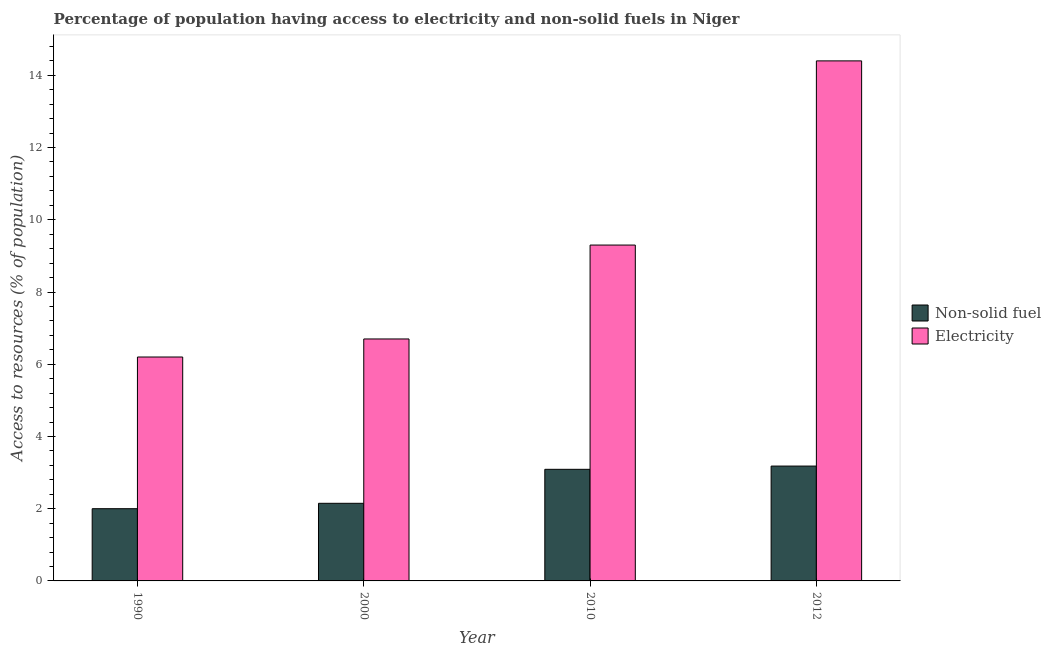How many groups of bars are there?
Give a very brief answer. 4. How many bars are there on the 3rd tick from the left?
Ensure brevity in your answer.  2. In how many cases, is the number of bars for a given year not equal to the number of legend labels?
Keep it short and to the point. 0. What is the percentage of population having access to non-solid fuel in 2000?
Provide a short and direct response. 2.15. Across all years, what is the maximum percentage of population having access to non-solid fuel?
Ensure brevity in your answer.  3.18. Across all years, what is the minimum percentage of population having access to non-solid fuel?
Give a very brief answer. 2. What is the total percentage of population having access to non-solid fuel in the graph?
Provide a short and direct response. 10.42. What is the difference between the percentage of population having access to non-solid fuel in 1990 and that in 2000?
Provide a succinct answer. -0.15. What is the difference between the percentage of population having access to electricity in 1990 and the percentage of population having access to non-solid fuel in 2000?
Your response must be concise. -0.5. What is the average percentage of population having access to non-solid fuel per year?
Offer a terse response. 2.6. In the year 1990, what is the difference between the percentage of population having access to electricity and percentage of population having access to non-solid fuel?
Offer a terse response. 0. What is the ratio of the percentage of population having access to electricity in 2010 to that in 2012?
Offer a very short reply. 0.65. What is the difference between the highest and the second highest percentage of population having access to non-solid fuel?
Offer a terse response. 0.09. What is the difference between the highest and the lowest percentage of population having access to electricity?
Offer a terse response. 8.2. Is the sum of the percentage of population having access to electricity in 2000 and 2012 greater than the maximum percentage of population having access to non-solid fuel across all years?
Make the answer very short. Yes. What does the 2nd bar from the left in 1990 represents?
Provide a short and direct response. Electricity. What does the 2nd bar from the right in 2000 represents?
Ensure brevity in your answer.  Non-solid fuel. How many bars are there?
Keep it short and to the point. 8. Are all the bars in the graph horizontal?
Keep it short and to the point. No. Are the values on the major ticks of Y-axis written in scientific E-notation?
Give a very brief answer. No. Does the graph contain grids?
Provide a succinct answer. No. How many legend labels are there?
Give a very brief answer. 2. What is the title of the graph?
Offer a terse response. Percentage of population having access to electricity and non-solid fuels in Niger. Does "constant 2005 US$" appear as one of the legend labels in the graph?
Keep it short and to the point. No. What is the label or title of the X-axis?
Keep it short and to the point. Year. What is the label or title of the Y-axis?
Provide a short and direct response. Access to resources (% of population). What is the Access to resources (% of population) in Non-solid fuel in 1990?
Ensure brevity in your answer.  2. What is the Access to resources (% of population) in Electricity in 1990?
Your answer should be very brief. 6.2. What is the Access to resources (% of population) in Non-solid fuel in 2000?
Offer a terse response. 2.15. What is the Access to resources (% of population) in Non-solid fuel in 2010?
Provide a succinct answer. 3.09. What is the Access to resources (% of population) in Electricity in 2010?
Your answer should be compact. 9.3. What is the Access to resources (% of population) of Non-solid fuel in 2012?
Keep it short and to the point. 3.18. Across all years, what is the maximum Access to resources (% of population) of Non-solid fuel?
Give a very brief answer. 3.18. Across all years, what is the minimum Access to resources (% of population) of Non-solid fuel?
Ensure brevity in your answer.  2. Across all years, what is the minimum Access to resources (% of population) in Electricity?
Keep it short and to the point. 6.2. What is the total Access to resources (% of population) in Non-solid fuel in the graph?
Keep it short and to the point. 10.42. What is the total Access to resources (% of population) in Electricity in the graph?
Provide a short and direct response. 36.6. What is the difference between the Access to resources (% of population) in Non-solid fuel in 1990 and that in 2000?
Offer a terse response. -0.15. What is the difference between the Access to resources (% of population) of Electricity in 1990 and that in 2000?
Your response must be concise. -0.5. What is the difference between the Access to resources (% of population) in Non-solid fuel in 1990 and that in 2010?
Make the answer very short. -1.09. What is the difference between the Access to resources (% of population) of Non-solid fuel in 1990 and that in 2012?
Provide a short and direct response. -1.18. What is the difference between the Access to resources (% of population) in Non-solid fuel in 2000 and that in 2010?
Provide a succinct answer. -0.94. What is the difference between the Access to resources (% of population) in Electricity in 2000 and that in 2010?
Your response must be concise. -2.6. What is the difference between the Access to resources (% of population) of Non-solid fuel in 2000 and that in 2012?
Your answer should be very brief. -1.03. What is the difference between the Access to resources (% of population) of Non-solid fuel in 2010 and that in 2012?
Keep it short and to the point. -0.09. What is the difference between the Access to resources (% of population) in Electricity in 2010 and that in 2012?
Give a very brief answer. -5.1. What is the difference between the Access to resources (% of population) in Non-solid fuel in 1990 and the Access to resources (% of population) in Electricity in 2000?
Give a very brief answer. -4.7. What is the difference between the Access to resources (% of population) in Non-solid fuel in 1990 and the Access to resources (% of population) in Electricity in 2010?
Make the answer very short. -7.3. What is the difference between the Access to resources (% of population) of Non-solid fuel in 2000 and the Access to resources (% of population) of Electricity in 2010?
Your answer should be very brief. -7.15. What is the difference between the Access to resources (% of population) in Non-solid fuel in 2000 and the Access to resources (% of population) in Electricity in 2012?
Offer a very short reply. -12.25. What is the difference between the Access to resources (% of population) of Non-solid fuel in 2010 and the Access to resources (% of population) of Electricity in 2012?
Provide a succinct answer. -11.31. What is the average Access to resources (% of population) in Non-solid fuel per year?
Your answer should be very brief. 2.6. What is the average Access to resources (% of population) of Electricity per year?
Your response must be concise. 9.15. In the year 2000, what is the difference between the Access to resources (% of population) in Non-solid fuel and Access to resources (% of population) in Electricity?
Keep it short and to the point. -4.55. In the year 2010, what is the difference between the Access to resources (% of population) of Non-solid fuel and Access to resources (% of population) of Electricity?
Make the answer very short. -6.21. In the year 2012, what is the difference between the Access to resources (% of population) in Non-solid fuel and Access to resources (% of population) in Electricity?
Ensure brevity in your answer.  -11.22. What is the ratio of the Access to resources (% of population) of Non-solid fuel in 1990 to that in 2000?
Give a very brief answer. 0.93. What is the ratio of the Access to resources (% of population) of Electricity in 1990 to that in 2000?
Your answer should be compact. 0.93. What is the ratio of the Access to resources (% of population) in Non-solid fuel in 1990 to that in 2010?
Keep it short and to the point. 0.65. What is the ratio of the Access to resources (% of population) of Non-solid fuel in 1990 to that in 2012?
Offer a very short reply. 0.63. What is the ratio of the Access to resources (% of population) of Electricity in 1990 to that in 2012?
Provide a succinct answer. 0.43. What is the ratio of the Access to resources (% of population) in Non-solid fuel in 2000 to that in 2010?
Your response must be concise. 0.7. What is the ratio of the Access to resources (% of population) in Electricity in 2000 to that in 2010?
Provide a succinct answer. 0.72. What is the ratio of the Access to resources (% of population) in Non-solid fuel in 2000 to that in 2012?
Your response must be concise. 0.68. What is the ratio of the Access to resources (% of population) in Electricity in 2000 to that in 2012?
Provide a short and direct response. 0.47. What is the ratio of the Access to resources (% of population) in Non-solid fuel in 2010 to that in 2012?
Offer a terse response. 0.97. What is the ratio of the Access to resources (% of population) in Electricity in 2010 to that in 2012?
Provide a succinct answer. 0.65. What is the difference between the highest and the second highest Access to resources (% of population) in Non-solid fuel?
Make the answer very short. 0.09. What is the difference between the highest and the second highest Access to resources (% of population) in Electricity?
Your answer should be very brief. 5.1. What is the difference between the highest and the lowest Access to resources (% of population) in Non-solid fuel?
Your response must be concise. 1.18. 